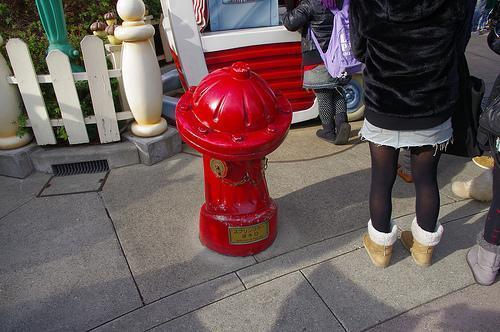How many fire hydrants are in the image?
Give a very brief answer. 1. 